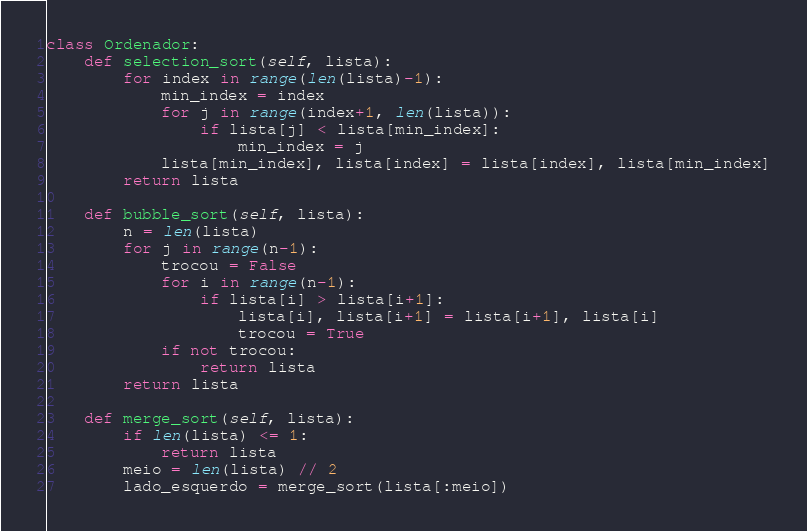<code> <loc_0><loc_0><loc_500><loc_500><_Python_>class Ordenador:
	def selection_sort(self, lista):
		for index in range(len(lista)-1):
			min_index = index
			for j in range(index+1, len(lista)):
				if lista[j] < lista[min_index]:
					min_index = j 
			lista[min_index], lista[index] = lista[index], lista[min_index]
		return lista

	def bubble_sort(self, lista):
		n = len(lista)
		for j in range(n-1):
			trocou = False
			for i in range(n-1):
				if lista[i] > lista[i+1]:
					lista[i], lista[i+1] = lista[i+1], lista[i]
					trocou = True 
			if not trocou:
				return lista
		return lista

	def merge_sort(self, lista):
		if len(lista) <= 1:
			return lista 
		meio = len(lista) // 2
		lado_esquerdo = merge_sort(lista[:meio])</code> 